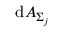<formula> <loc_0><loc_0><loc_500><loc_500>d A _ { \Sigma _ { j } }</formula> 